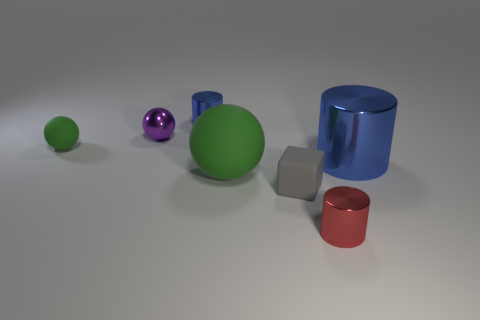Add 1 big cyan things. How many objects exist? 8 Subtract all cylinders. How many objects are left? 4 Add 2 big blue things. How many big blue things are left? 3 Add 3 brown metal objects. How many brown metal objects exist? 3 Subtract 0 green cylinders. How many objects are left? 7 Subtract all red matte blocks. Subtract all small blue metallic cylinders. How many objects are left? 6 